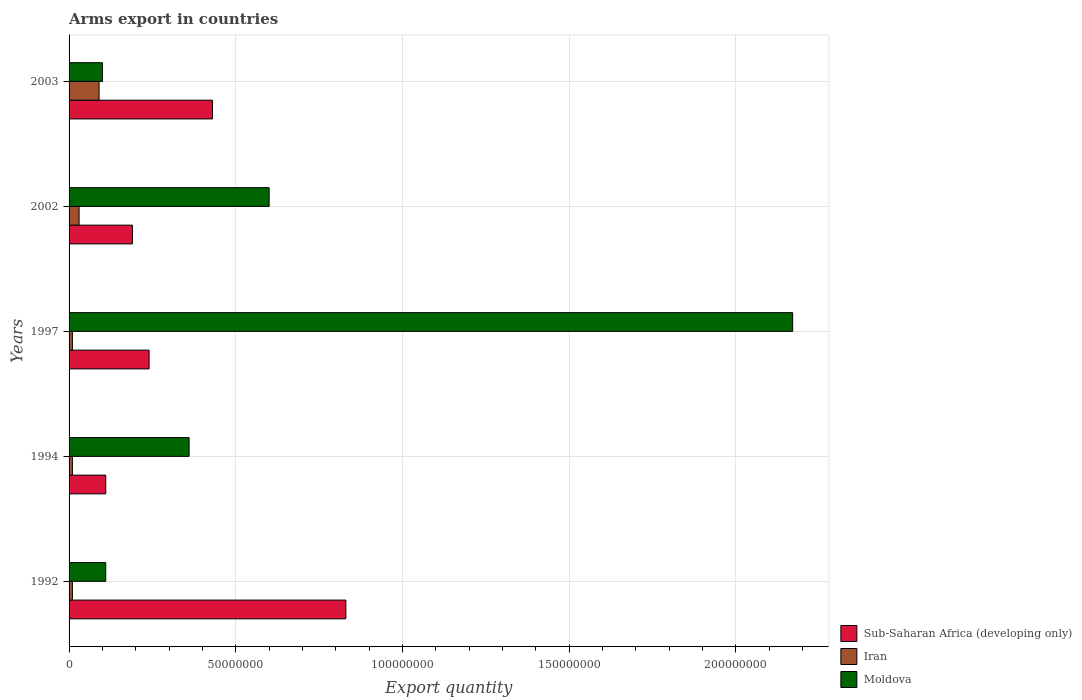How many different coloured bars are there?
Offer a very short reply. 3. Are the number of bars on each tick of the Y-axis equal?
Give a very brief answer. Yes. How many bars are there on the 3rd tick from the top?
Make the answer very short. 3. How many bars are there on the 3rd tick from the bottom?
Your answer should be very brief. 3. What is the total arms export in Iran in 1992?
Provide a succinct answer. 1.00e+06. Across all years, what is the maximum total arms export in Sub-Saharan Africa (developing only)?
Give a very brief answer. 8.30e+07. Across all years, what is the minimum total arms export in Sub-Saharan Africa (developing only)?
Offer a terse response. 1.10e+07. In which year was the total arms export in Moldova minimum?
Provide a succinct answer. 2003. What is the total total arms export in Moldova in the graph?
Your response must be concise. 3.34e+08. What is the difference between the total arms export in Sub-Saharan Africa (developing only) in 1992 and that in 1994?
Offer a terse response. 7.20e+07. What is the difference between the total arms export in Moldova in 1994 and the total arms export in Sub-Saharan Africa (developing only) in 1992?
Keep it short and to the point. -4.70e+07. What is the average total arms export in Iran per year?
Your answer should be very brief. 3.00e+06. In the year 2002, what is the difference between the total arms export in Moldova and total arms export in Sub-Saharan Africa (developing only)?
Offer a terse response. 4.10e+07. In how many years, is the total arms export in Moldova greater than 140000000 ?
Your answer should be compact. 1. What is the ratio of the total arms export in Moldova in 1992 to that in 1994?
Offer a very short reply. 0.31. Is the total arms export in Moldova in 1994 less than that in 2002?
Provide a short and direct response. Yes. Is the difference between the total arms export in Moldova in 1992 and 1994 greater than the difference between the total arms export in Sub-Saharan Africa (developing only) in 1992 and 1994?
Your answer should be very brief. No. What is the difference between the highest and the second highest total arms export in Moldova?
Your answer should be compact. 1.57e+08. What is the difference between the highest and the lowest total arms export in Iran?
Make the answer very short. 8.00e+06. In how many years, is the total arms export in Sub-Saharan Africa (developing only) greater than the average total arms export in Sub-Saharan Africa (developing only) taken over all years?
Offer a very short reply. 2. What does the 2nd bar from the top in 1992 represents?
Offer a terse response. Iran. What does the 1st bar from the bottom in 1994 represents?
Provide a short and direct response. Sub-Saharan Africa (developing only). Are all the bars in the graph horizontal?
Provide a short and direct response. Yes. Are the values on the major ticks of X-axis written in scientific E-notation?
Ensure brevity in your answer.  No. Does the graph contain grids?
Give a very brief answer. Yes. Where does the legend appear in the graph?
Ensure brevity in your answer.  Bottom right. How many legend labels are there?
Offer a terse response. 3. What is the title of the graph?
Provide a succinct answer. Arms export in countries. Does "Cambodia" appear as one of the legend labels in the graph?
Your answer should be compact. No. What is the label or title of the X-axis?
Offer a very short reply. Export quantity. What is the Export quantity in Sub-Saharan Africa (developing only) in 1992?
Offer a very short reply. 8.30e+07. What is the Export quantity in Iran in 1992?
Your answer should be very brief. 1.00e+06. What is the Export quantity of Moldova in 1992?
Offer a very short reply. 1.10e+07. What is the Export quantity in Sub-Saharan Africa (developing only) in 1994?
Provide a short and direct response. 1.10e+07. What is the Export quantity of Moldova in 1994?
Your response must be concise. 3.60e+07. What is the Export quantity in Sub-Saharan Africa (developing only) in 1997?
Make the answer very short. 2.40e+07. What is the Export quantity in Iran in 1997?
Ensure brevity in your answer.  1.00e+06. What is the Export quantity of Moldova in 1997?
Offer a terse response. 2.17e+08. What is the Export quantity in Sub-Saharan Africa (developing only) in 2002?
Provide a succinct answer. 1.90e+07. What is the Export quantity in Moldova in 2002?
Give a very brief answer. 6.00e+07. What is the Export quantity in Sub-Saharan Africa (developing only) in 2003?
Provide a succinct answer. 4.30e+07. What is the Export quantity of Iran in 2003?
Make the answer very short. 9.00e+06. What is the Export quantity in Moldova in 2003?
Make the answer very short. 1.00e+07. Across all years, what is the maximum Export quantity of Sub-Saharan Africa (developing only)?
Give a very brief answer. 8.30e+07. Across all years, what is the maximum Export quantity of Iran?
Your answer should be compact. 9.00e+06. Across all years, what is the maximum Export quantity of Moldova?
Provide a succinct answer. 2.17e+08. Across all years, what is the minimum Export quantity of Sub-Saharan Africa (developing only)?
Provide a short and direct response. 1.10e+07. Across all years, what is the minimum Export quantity in Iran?
Make the answer very short. 1.00e+06. Across all years, what is the minimum Export quantity in Moldova?
Ensure brevity in your answer.  1.00e+07. What is the total Export quantity of Sub-Saharan Africa (developing only) in the graph?
Keep it short and to the point. 1.80e+08. What is the total Export quantity of Iran in the graph?
Make the answer very short. 1.50e+07. What is the total Export quantity in Moldova in the graph?
Give a very brief answer. 3.34e+08. What is the difference between the Export quantity of Sub-Saharan Africa (developing only) in 1992 and that in 1994?
Offer a terse response. 7.20e+07. What is the difference between the Export quantity in Iran in 1992 and that in 1994?
Your answer should be very brief. 0. What is the difference between the Export quantity of Moldova in 1992 and that in 1994?
Provide a short and direct response. -2.50e+07. What is the difference between the Export quantity of Sub-Saharan Africa (developing only) in 1992 and that in 1997?
Your answer should be very brief. 5.90e+07. What is the difference between the Export quantity in Moldova in 1992 and that in 1997?
Your answer should be compact. -2.06e+08. What is the difference between the Export quantity in Sub-Saharan Africa (developing only) in 1992 and that in 2002?
Keep it short and to the point. 6.40e+07. What is the difference between the Export quantity of Iran in 1992 and that in 2002?
Keep it short and to the point. -2.00e+06. What is the difference between the Export quantity of Moldova in 1992 and that in 2002?
Ensure brevity in your answer.  -4.90e+07. What is the difference between the Export quantity in Sub-Saharan Africa (developing only) in 1992 and that in 2003?
Offer a terse response. 4.00e+07. What is the difference between the Export quantity of Iran in 1992 and that in 2003?
Offer a very short reply. -8.00e+06. What is the difference between the Export quantity of Sub-Saharan Africa (developing only) in 1994 and that in 1997?
Provide a short and direct response. -1.30e+07. What is the difference between the Export quantity in Moldova in 1994 and that in 1997?
Your response must be concise. -1.81e+08. What is the difference between the Export quantity in Sub-Saharan Africa (developing only) in 1994 and that in 2002?
Give a very brief answer. -8.00e+06. What is the difference between the Export quantity of Iran in 1994 and that in 2002?
Make the answer very short. -2.00e+06. What is the difference between the Export quantity in Moldova in 1994 and that in 2002?
Give a very brief answer. -2.40e+07. What is the difference between the Export quantity of Sub-Saharan Africa (developing only) in 1994 and that in 2003?
Offer a very short reply. -3.20e+07. What is the difference between the Export quantity of Iran in 1994 and that in 2003?
Make the answer very short. -8.00e+06. What is the difference between the Export quantity of Moldova in 1994 and that in 2003?
Offer a very short reply. 2.60e+07. What is the difference between the Export quantity in Sub-Saharan Africa (developing only) in 1997 and that in 2002?
Keep it short and to the point. 5.00e+06. What is the difference between the Export quantity of Moldova in 1997 and that in 2002?
Offer a very short reply. 1.57e+08. What is the difference between the Export quantity in Sub-Saharan Africa (developing only) in 1997 and that in 2003?
Your answer should be very brief. -1.90e+07. What is the difference between the Export quantity in Iran in 1997 and that in 2003?
Ensure brevity in your answer.  -8.00e+06. What is the difference between the Export quantity in Moldova in 1997 and that in 2003?
Your response must be concise. 2.07e+08. What is the difference between the Export quantity in Sub-Saharan Africa (developing only) in 2002 and that in 2003?
Provide a short and direct response. -2.40e+07. What is the difference between the Export quantity of Iran in 2002 and that in 2003?
Offer a very short reply. -6.00e+06. What is the difference between the Export quantity in Sub-Saharan Africa (developing only) in 1992 and the Export quantity in Iran in 1994?
Your answer should be compact. 8.20e+07. What is the difference between the Export quantity in Sub-Saharan Africa (developing only) in 1992 and the Export quantity in Moldova in 1994?
Ensure brevity in your answer.  4.70e+07. What is the difference between the Export quantity in Iran in 1992 and the Export quantity in Moldova in 1994?
Offer a terse response. -3.50e+07. What is the difference between the Export quantity of Sub-Saharan Africa (developing only) in 1992 and the Export quantity of Iran in 1997?
Offer a very short reply. 8.20e+07. What is the difference between the Export quantity of Sub-Saharan Africa (developing only) in 1992 and the Export quantity of Moldova in 1997?
Offer a terse response. -1.34e+08. What is the difference between the Export quantity in Iran in 1992 and the Export quantity in Moldova in 1997?
Offer a very short reply. -2.16e+08. What is the difference between the Export quantity of Sub-Saharan Africa (developing only) in 1992 and the Export quantity of Iran in 2002?
Your response must be concise. 8.00e+07. What is the difference between the Export quantity in Sub-Saharan Africa (developing only) in 1992 and the Export quantity in Moldova in 2002?
Your answer should be very brief. 2.30e+07. What is the difference between the Export quantity in Iran in 1992 and the Export quantity in Moldova in 2002?
Give a very brief answer. -5.90e+07. What is the difference between the Export quantity in Sub-Saharan Africa (developing only) in 1992 and the Export quantity in Iran in 2003?
Offer a very short reply. 7.40e+07. What is the difference between the Export quantity in Sub-Saharan Africa (developing only) in 1992 and the Export quantity in Moldova in 2003?
Offer a terse response. 7.30e+07. What is the difference between the Export quantity of Iran in 1992 and the Export quantity of Moldova in 2003?
Your answer should be very brief. -9.00e+06. What is the difference between the Export quantity in Sub-Saharan Africa (developing only) in 1994 and the Export quantity in Iran in 1997?
Offer a terse response. 1.00e+07. What is the difference between the Export quantity in Sub-Saharan Africa (developing only) in 1994 and the Export quantity in Moldova in 1997?
Your answer should be compact. -2.06e+08. What is the difference between the Export quantity of Iran in 1994 and the Export quantity of Moldova in 1997?
Give a very brief answer. -2.16e+08. What is the difference between the Export quantity of Sub-Saharan Africa (developing only) in 1994 and the Export quantity of Moldova in 2002?
Keep it short and to the point. -4.90e+07. What is the difference between the Export quantity in Iran in 1994 and the Export quantity in Moldova in 2002?
Provide a short and direct response. -5.90e+07. What is the difference between the Export quantity of Sub-Saharan Africa (developing only) in 1994 and the Export quantity of Iran in 2003?
Offer a terse response. 2.00e+06. What is the difference between the Export quantity in Iran in 1994 and the Export quantity in Moldova in 2003?
Offer a terse response. -9.00e+06. What is the difference between the Export quantity in Sub-Saharan Africa (developing only) in 1997 and the Export quantity in Iran in 2002?
Provide a short and direct response. 2.10e+07. What is the difference between the Export quantity of Sub-Saharan Africa (developing only) in 1997 and the Export quantity of Moldova in 2002?
Make the answer very short. -3.60e+07. What is the difference between the Export quantity of Iran in 1997 and the Export quantity of Moldova in 2002?
Give a very brief answer. -5.90e+07. What is the difference between the Export quantity in Sub-Saharan Africa (developing only) in 1997 and the Export quantity in Iran in 2003?
Provide a short and direct response. 1.50e+07. What is the difference between the Export quantity in Sub-Saharan Africa (developing only) in 1997 and the Export quantity in Moldova in 2003?
Ensure brevity in your answer.  1.40e+07. What is the difference between the Export quantity in Iran in 1997 and the Export quantity in Moldova in 2003?
Offer a very short reply. -9.00e+06. What is the difference between the Export quantity in Sub-Saharan Africa (developing only) in 2002 and the Export quantity in Moldova in 2003?
Ensure brevity in your answer.  9.00e+06. What is the difference between the Export quantity of Iran in 2002 and the Export quantity of Moldova in 2003?
Offer a very short reply. -7.00e+06. What is the average Export quantity in Sub-Saharan Africa (developing only) per year?
Provide a succinct answer. 3.60e+07. What is the average Export quantity in Iran per year?
Provide a succinct answer. 3.00e+06. What is the average Export quantity of Moldova per year?
Provide a short and direct response. 6.68e+07. In the year 1992, what is the difference between the Export quantity in Sub-Saharan Africa (developing only) and Export quantity in Iran?
Your response must be concise. 8.20e+07. In the year 1992, what is the difference between the Export quantity of Sub-Saharan Africa (developing only) and Export quantity of Moldova?
Provide a short and direct response. 7.20e+07. In the year 1992, what is the difference between the Export quantity of Iran and Export quantity of Moldova?
Your response must be concise. -1.00e+07. In the year 1994, what is the difference between the Export quantity of Sub-Saharan Africa (developing only) and Export quantity of Moldova?
Keep it short and to the point. -2.50e+07. In the year 1994, what is the difference between the Export quantity in Iran and Export quantity in Moldova?
Give a very brief answer. -3.50e+07. In the year 1997, what is the difference between the Export quantity of Sub-Saharan Africa (developing only) and Export quantity of Iran?
Your response must be concise. 2.30e+07. In the year 1997, what is the difference between the Export quantity in Sub-Saharan Africa (developing only) and Export quantity in Moldova?
Ensure brevity in your answer.  -1.93e+08. In the year 1997, what is the difference between the Export quantity of Iran and Export quantity of Moldova?
Ensure brevity in your answer.  -2.16e+08. In the year 2002, what is the difference between the Export quantity of Sub-Saharan Africa (developing only) and Export quantity of Iran?
Make the answer very short. 1.60e+07. In the year 2002, what is the difference between the Export quantity in Sub-Saharan Africa (developing only) and Export quantity in Moldova?
Ensure brevity in your answer.  -4.10e+07. In the year 2002, what is the difference between the Export quantity of Iran and Export quantity of Moldova?
Provide a succinct answer. -5.70e+07. In the year 2003, what is the difference between the Export quantity in Sub-Saharan Africa (developing only) and Export quantity in Iran?
Offer a terse response. 3.40e+07. In the year 2003, what is the difference between the Export quantity in Sub-Saharan Africa (developing only) and Export quantity in Moldova?
Offer a very short reply. 3.30e+07. What is the ratio of the Export quantity in Sub-Saharan Africa (developing only) in 1992 to that in 1994?
Keep it short and to the point. 7.55. What is the ratio of the Export quantity in Moldova in 1992 to that in 1994?
Keep it short and to the point. 0.31. What is the ratio of the Export quantity in Sub-Saharan Africa (developing only) in 1992 to that in 1997?
Your response must be concise. 3.46. What is the ratio of the Export quantity in Moldova in 1992 to that in 1997?
Your answer should be very brief. 0.05. What is the ratio of the Export quantity of Sub-Saharan Africa (developing only) in 1992 to that in 2002?
Give a very brief answer. 4.37. What is the ratio of the Export quantity of Iran in 1992 to that in 2002?
Provide a succinct answer. 0.33. What is the ratio of the Export quantity in Moldova in 1992 to that in 2002?
Offer a very short reply. 0.18. What is the ratio of the Export quantity in Sub-Saharan Africa (developing only) in 1992 to that in 2003?
Provide a short and direct response. 1.93. What is the ratio of the Export quantity in Iran in 1992 to that in 2003?
Give a very brief answer. 0.11. What is the ratio of the Export quantity in Moldova in 1992 to that in 2003?
Your response must be concise. 1.1. What is the ratio of the Export quantity of Sub-Saharan Africa (developing only) in 1994 to that in 1997?
Make the answer very short. 0.46. What is the ratio of the Export quantity in Moldova in 1994 to that in 1997?
Your answer should be compact. 0.17. What is the ratio of the Export quantity of Sub-Saharan Africa (developing only) in 1994 to that in 2002?
Make the answer very short. 0.58. What is the ratio of the Export quantity of Sub-Saharan Africa (developing only) in 1994 to that in 2003?
Your answer should be compact. 0.26. What is the ratio of the Export quantity in Moldova in 1994 to that in 2003?
Provide a succinct answer. 3.6. What is the ratio of the Export quantity in Sub-Saharan Africa (developing only) in 1997 to that in 2002?
Offer a terse response. 1.26. What is the ratio of the Export quantity in Moldova in 1997 to that in 2002?
Offer a terse response. 3.62. What is the ratio of the Export quantity of Sub-Saharan Africa (developing only) in 1997 to that in 2003?
Your answer should be very brief. 0.56. What is the ratio of the Export quantity in Moldova in 1997 to that in 2003?
Keep it short and to the point. 21.7. What is the ratio of the Export quantity in Sub-Saharan Africa (developing only) in 2002 to that in 2003?
Your response must be concise. 0.44. What is the ratio of the Export quantity in Iran in 2002 to that in 2003?
Offer a terse response. 0.33. What is the difference between the highest and the second highest Export quantity of Sub-Saharan Africa (developing only)?
Your answer should be very brief. 4.00e+07. What is the difference between the highest and the second highest Export quantity in Moldova?
Make the answer very short. 1.57e+08. What is the difference between the highest and the lowest Export quantity in Sub-Saharan Africa (developing only)?
Ensure brevity in your answer.  7.20e+07. What is the difference between the highest and the lowest Export quantity of Iran?
Offer a very short reply. 8.00e+06. What is the difference between the highest and the lowest Export quantity in Moldova?
Ensure brevity in your answer.  2.07e+08. 